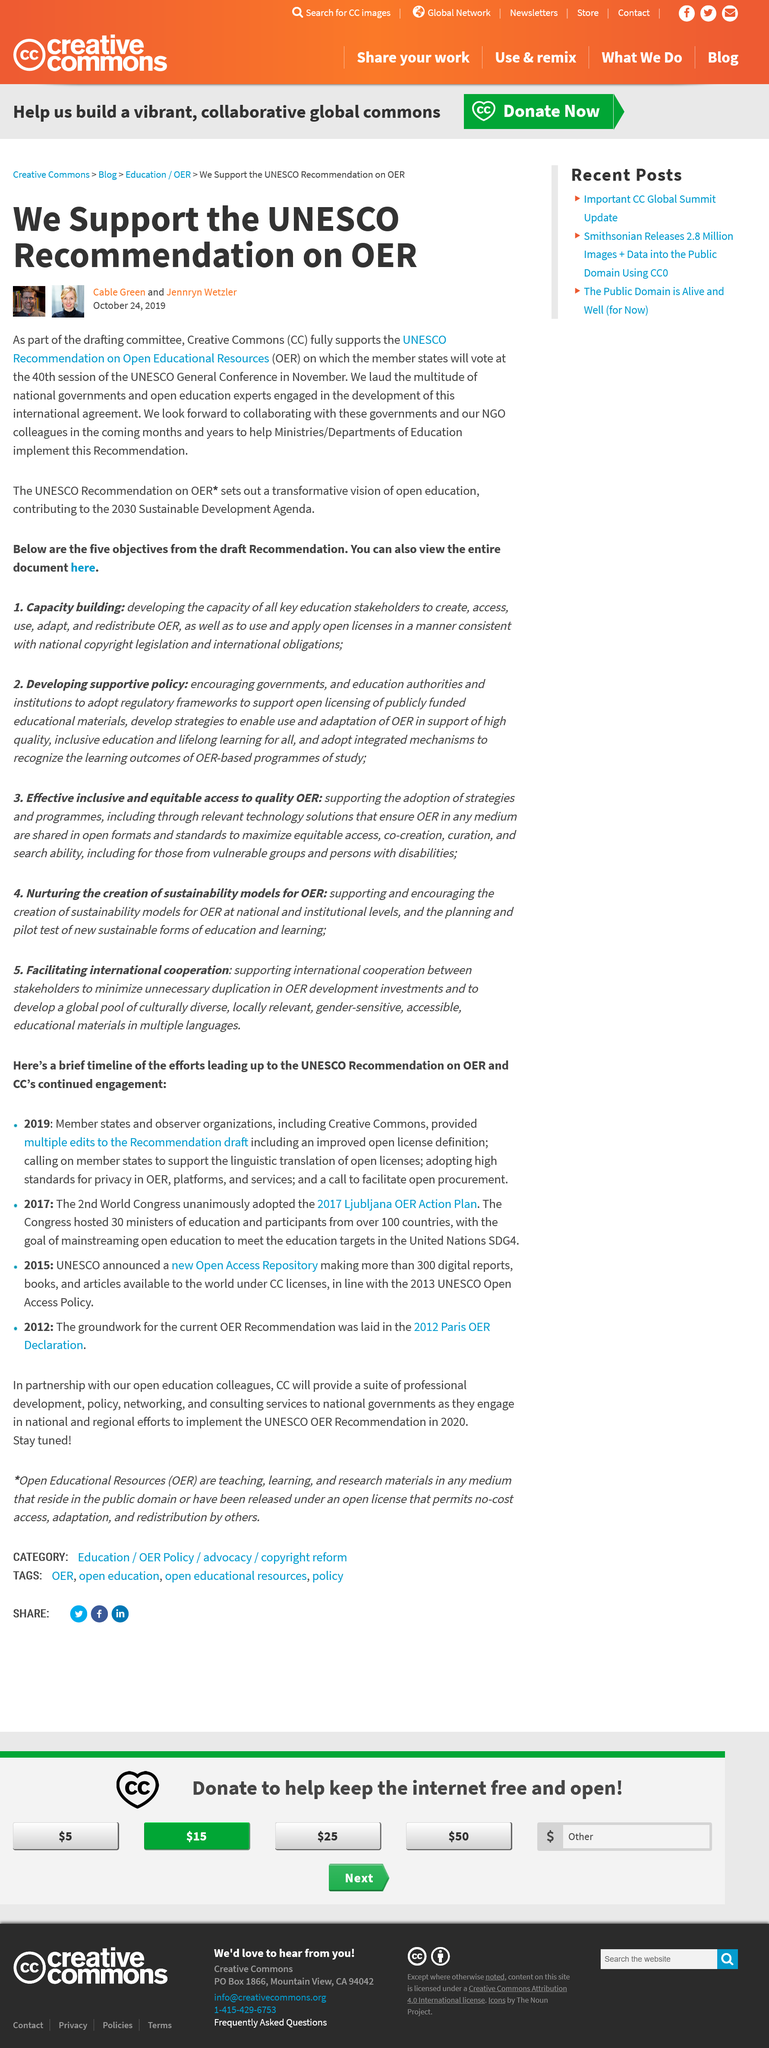Indicate a few pertinent items in this graphic. OER stands for Open Educational Resources, which are educational materials that are made freely available to anyone to use, edit, and distribute. The article supports the United Nations Educational, Scientific, and Cultural Organization (UNESCO) Recommendation on Open Educational Resources (OER). CC" is an abbreviation that stands for "Creative Commons. 